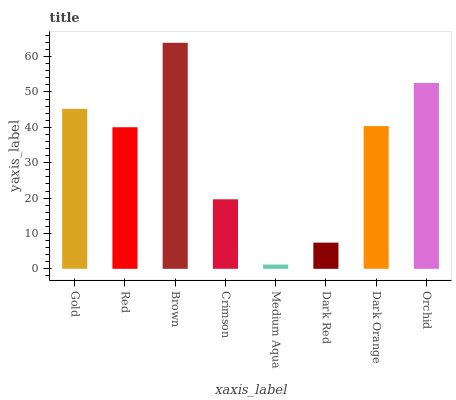Is Medium Aqua the minimum?
Answer yes or no. Yes. Is Brown the maximum?
Answer yes or no. Yes. Is Red the minimum?
Answer yes or no. No. Is Red the maximum?
Answer yes or no. No. Is Gold greater than Red?
Answer yes or no. Yes. Is Red less than Gold?
Answer yes or no. Yes. Is Red greater than Gold?
Answer yes or no. No. Is Gold less than Red?
Answer yes or no. No. Is Dark Orange the high median?
Answer yes or no. Yes. Is Red the low median?
Answer yes or no. Yes. Is Red the high median?
Answer yes or no. No. Is Dark Orange the low median?
Answer yes or no. No. 